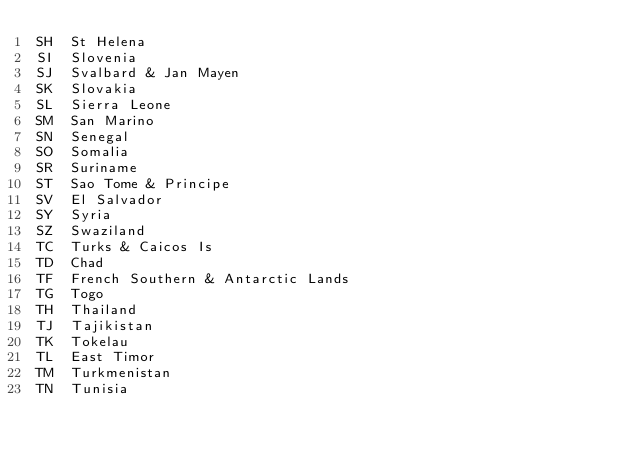<code> <loc_0><loc_0><loc_500><loc_500><_SQL_>SH	St Helena
SI	Slovenia
SJ	Svalbard & Jan Mayen
SK	Slovakia
SL	Sierra Leone
SM	San Marino
SN	Senegal
SO	Somalia
SR	Suriname
ST	Sao Tome & Principe
SV	El Salvador
SY	Syria
SZ	Swaziland
TC	Turks & Caicos Is
TD	Chad
TF	French Southern & Antarctic Lands
TG	Togo
TH	Thailand
TJ	Tajikistan
TK	Tokelau
TL	East Timor
TM	Turkmenistan
TN	Tunisia</code> 